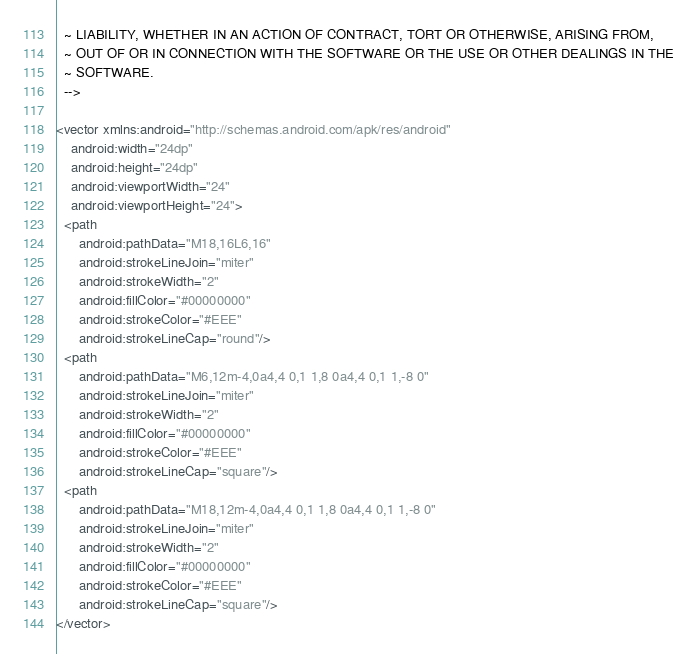<code> <loc_0><loc_0><loc_500><loc_500><_XML_>  ~ LIABILITY, WHETHER IN AN ACTION OF CONTRACT, TORT OR OTHERWISE, ARISING FROM,
  ~ OUT OF OR IN CONNECTION WITH THE SOFTWARE OR THE USE OR OTHER DEALINGS IN THE
  ~ SOFTWARE.
  -->

<vector xmlns:android="http://schemas.android.com/apk/res/android"
    android:width="24dp"
    android:height="24dp"
    android:viewportWidth="24"
    android:viewportHeight="24">
  <path
      android:pathData="M18,16L6,16"
      android:strokeLineJoin="miter"
      android:strokeWidth="2"
      android:fillColor="#00000000"
      android:strokeColor="#EEE"
      android:strokeLineCap="round"/>
  <path
      android:pathData="M6,12m-4,0a4,4 0,1 1,8 0a4,4 0,1 1,-8 0"
      android:strokeLineJoin="miter"
      android:strokeWidth="2"
      android:fillColor="#00000000"
      android:strokeColor="#EEE"
      android:strokeLineCap="square"/>
  <path
      android:pathData="M18,12m-4,0a4,4 0,1 1,8 0a4,4 0,1 1,-8 0"
      android:strokeLineJoin="miter"
      android:strokeWidth="2"
      android:fillColor="#00000000"
      android:strokeColor="#EEE"
      android:strokeLineCap="square"/>
</vector>
</code> 